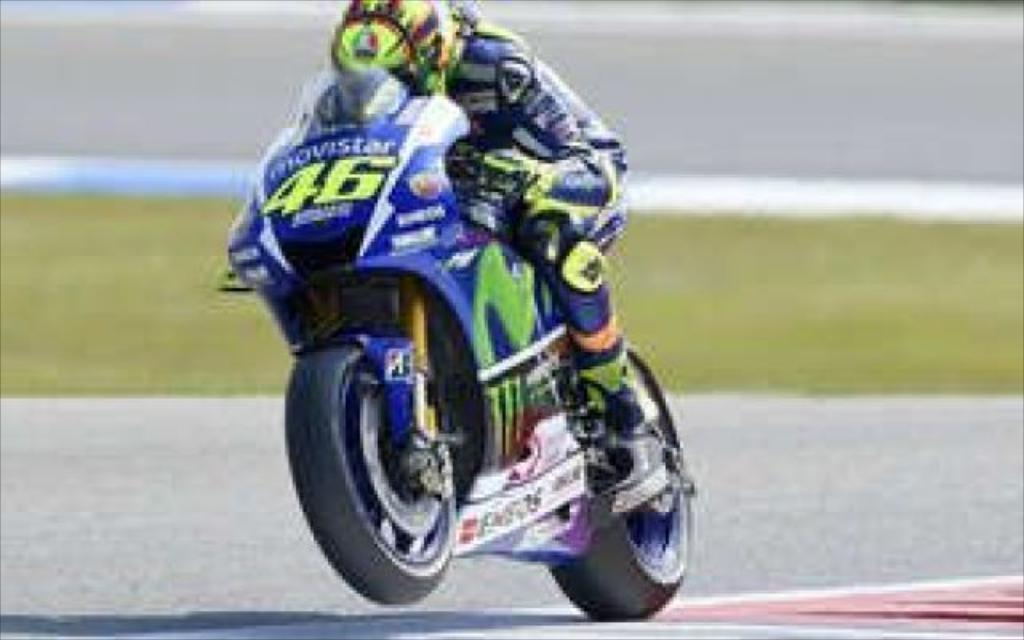What is the main subject of the image? There is a person riding a motorcycle in the image. Where is the person riding the motorcycle? The person is on the road. What can be seen in the background of the image? There is grass visible in the background of the image. Can you see the moon in the image? No, the moon is not visible in the image. The image only shows a person riding a motorcycle on the road with grass visible in the background. 